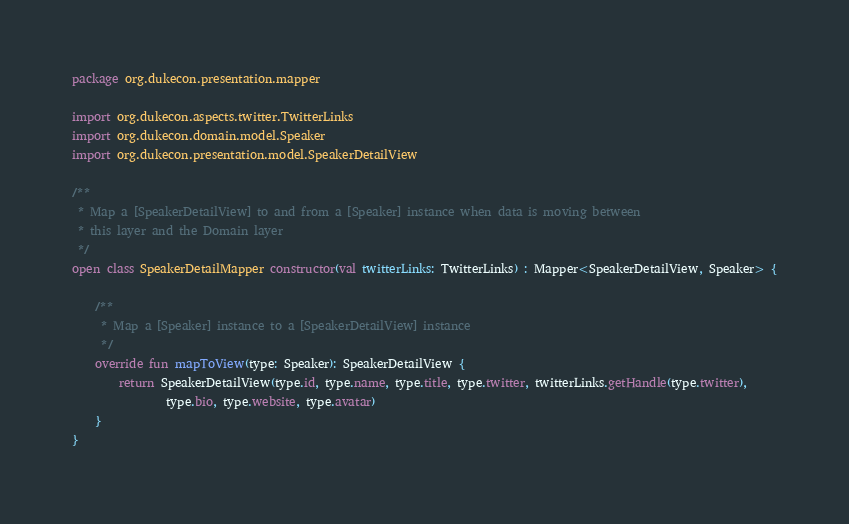Convert code to text. <code><loc_0><loc_0><loc_500><loc_500><_Kotlin_>package org.dukecon.presentation.mapper

import org.dukecon.aspects.twitter.TwitterLinks
import org.dukecon.domain.model.Speaker
import org.dukecon.presentation.model.SpeakerDetailView

/**
 * Map a [SpeakerDetailView] to and from a [Speaker] instance when data is moving between
 * this layer and the Domain layer
 */
open class SpeakerDetailMapper constructor(val twitterLinks: TwitterLinks) : Mapper<SpeakerDetailView, Speaker> {

    /**
     * Map a [Speaker] instance to a [SpeakerDetailView] instance
     */
    override fun mapToView(type: Speaker): SpeakerDetailView {
        return SpeakerDetailView(type.id, type.name, type.title, type.twitter, twitterLinks.getHandle(type.twitter),
                type.bio, type.website, type.avatar)
    }
}</code> 